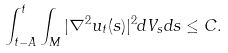Convert formula to latex. <formula><loc_0><loc_0><loc_500><loc_500>\int _ { t - A } ^ { t } \int _ { M } | \nabla ^ { 2 } u _ { t } ( s ) | ^ { 2 } d V _ { s } d s \leq C .</formula> 